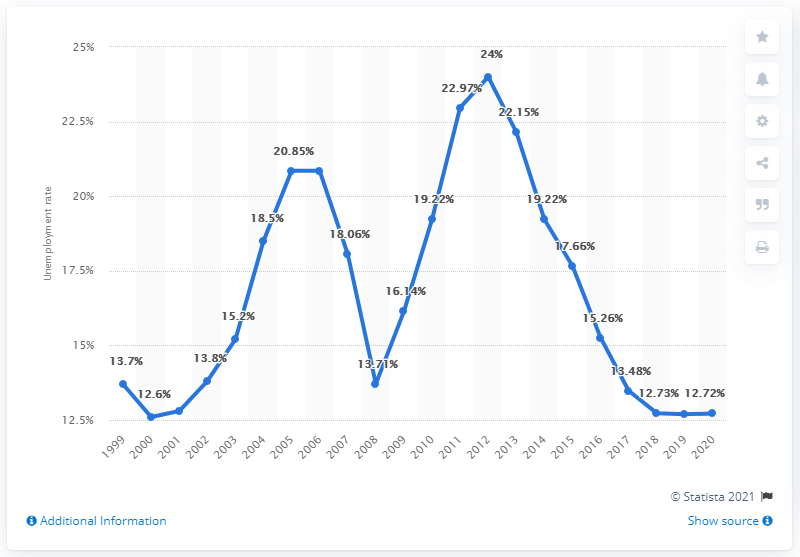Outline some significant characteristics in this image. The unemployment rate in Serbia in 2020 was 12.72%. 